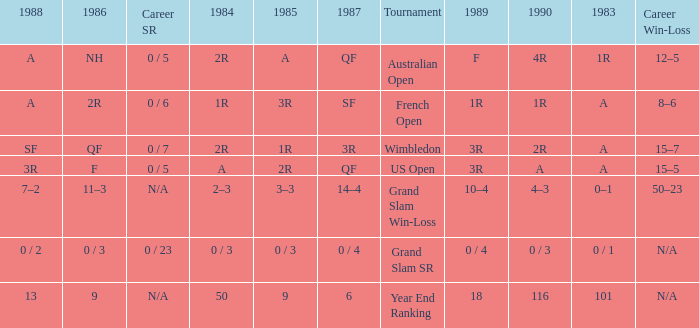Can you parse all the data within this table? {'header': ['1988', '1986', 'Career SR', '1984', '1985', '1987', 'Tournament', '1989', '1990', '1983', 'Career Win-Loss'], 'rows': [['A', 'NH', '0 / 5', '2R', 'A', 'QF', 'Australian Open', 'F', '4R', '1R', '12–5'], ['A', '2R', '0 / 6', '1R', '3R', 'SF', 'French Open', '1R', '1R', 'A', '8–6'], ['SF', 'QF', '0 / 7', '2R', '1R', '3R', 'Wimbledon', '3R', '2R', 'A', '15–7'], ['3R', 'F', '0 / 5', 'A', '2R', 'QF', 'US Open', '3R', 'A', 'A', '15–5'], ['7–2', '11–3', 'N/A', '2–3', '3–3', '14–4', 'Grand Slam Win-Loss', '10–4', '4–3', '0–1', '50–23'], ['0 / 2', '0 / 3', '0 / 23', '0 / 3', '0 / 3', '0 / 4', 'Grand Slam SR', '0 / 4', '0 / 3', '0 / 1', 'N/A'], ['13', '9', 'N/A', '50', '9', '6', 'Year End Ranking', '18', '116', '101', 'N/A']]} What is the result in 1985 when the career win-loss is n/a, and 0 / 23 as the career SR? 0 / 3. 